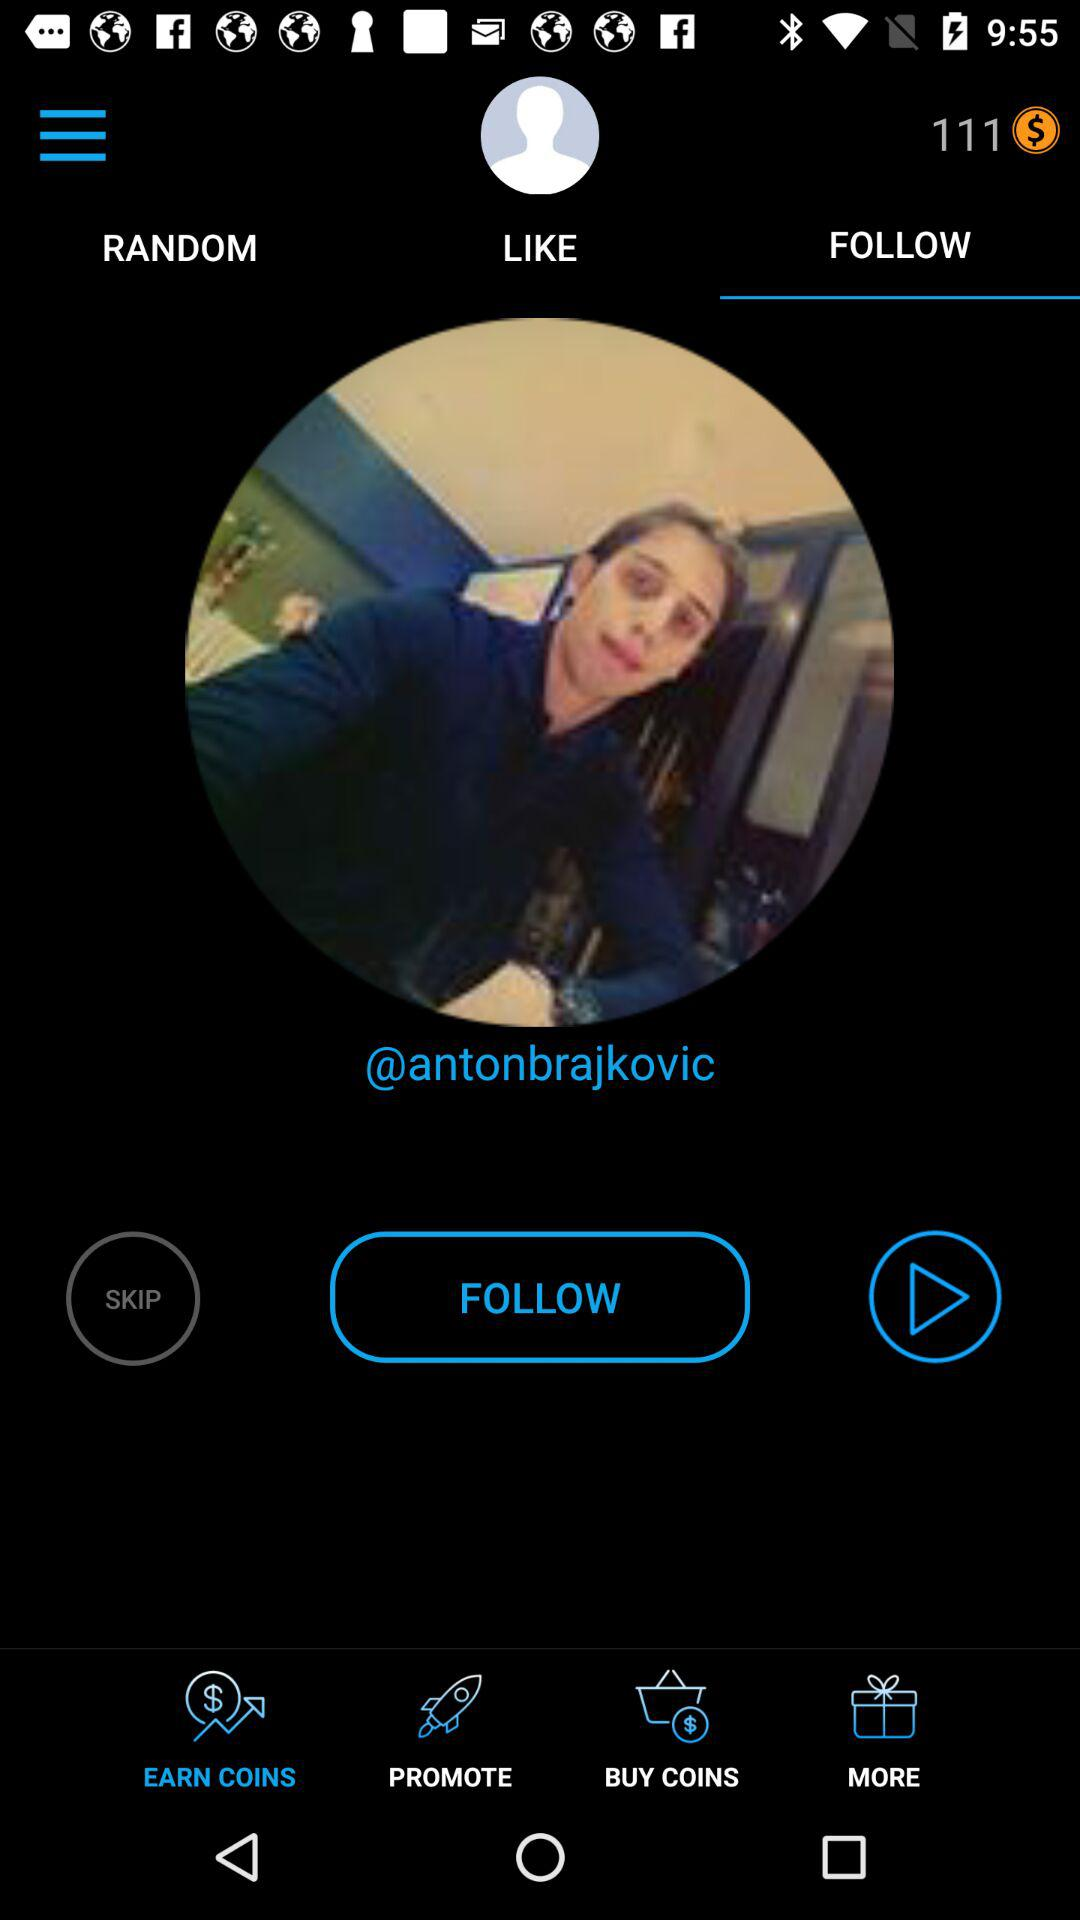What is the username? The username is "@antonbrajkovic". 